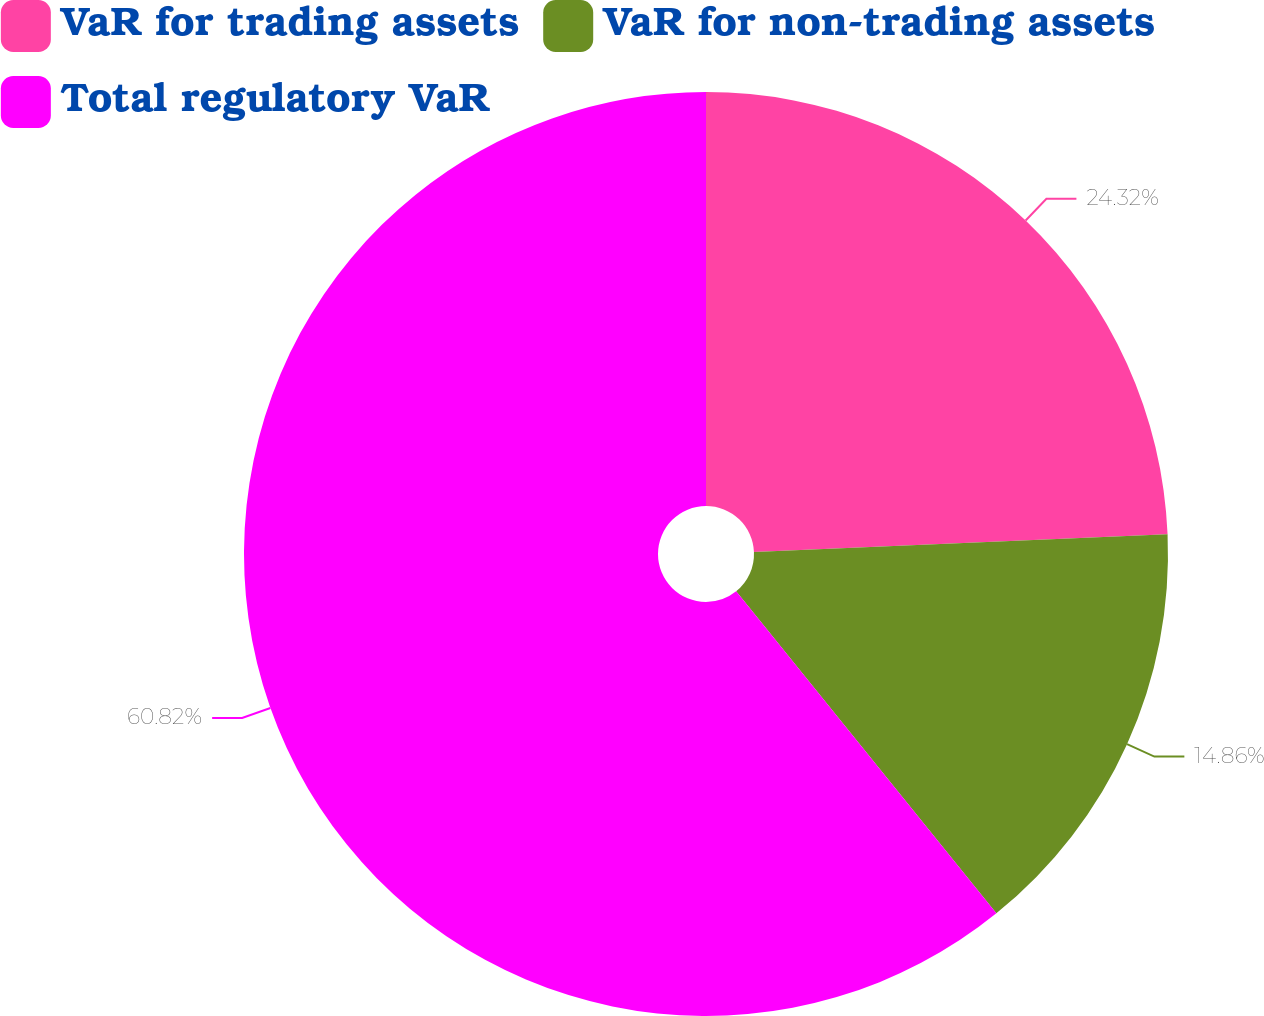<chart> <loc_0><loc_0><loc_500><loc_500><pie_chart><fcel>VaR for trading assets<fcel>VaR for non-trading assets<fcel>Total regulatory VaR<nl><fcel>24.32%<fcel>14.86%<fcel>60.81%<nl></chart> 